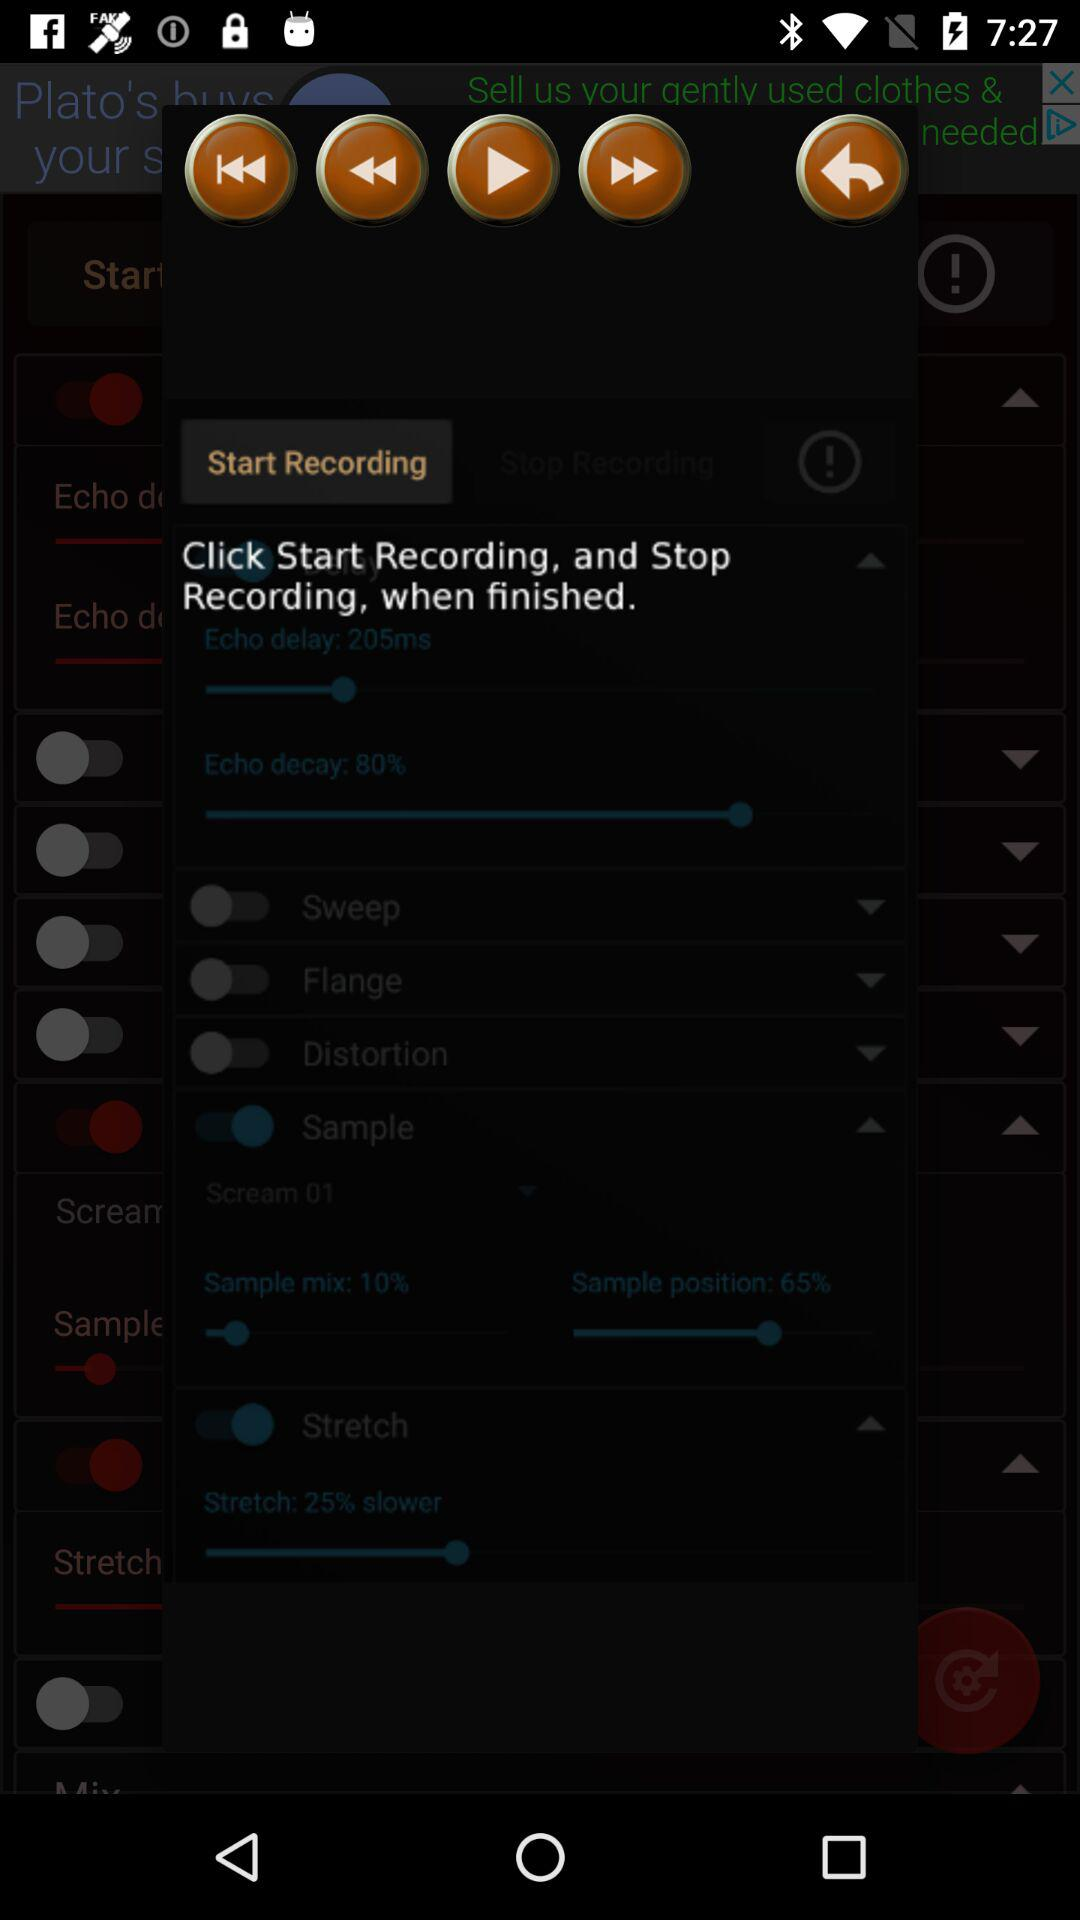What is the percentage of the sample mix? The percentage of the sample mix is 10. 